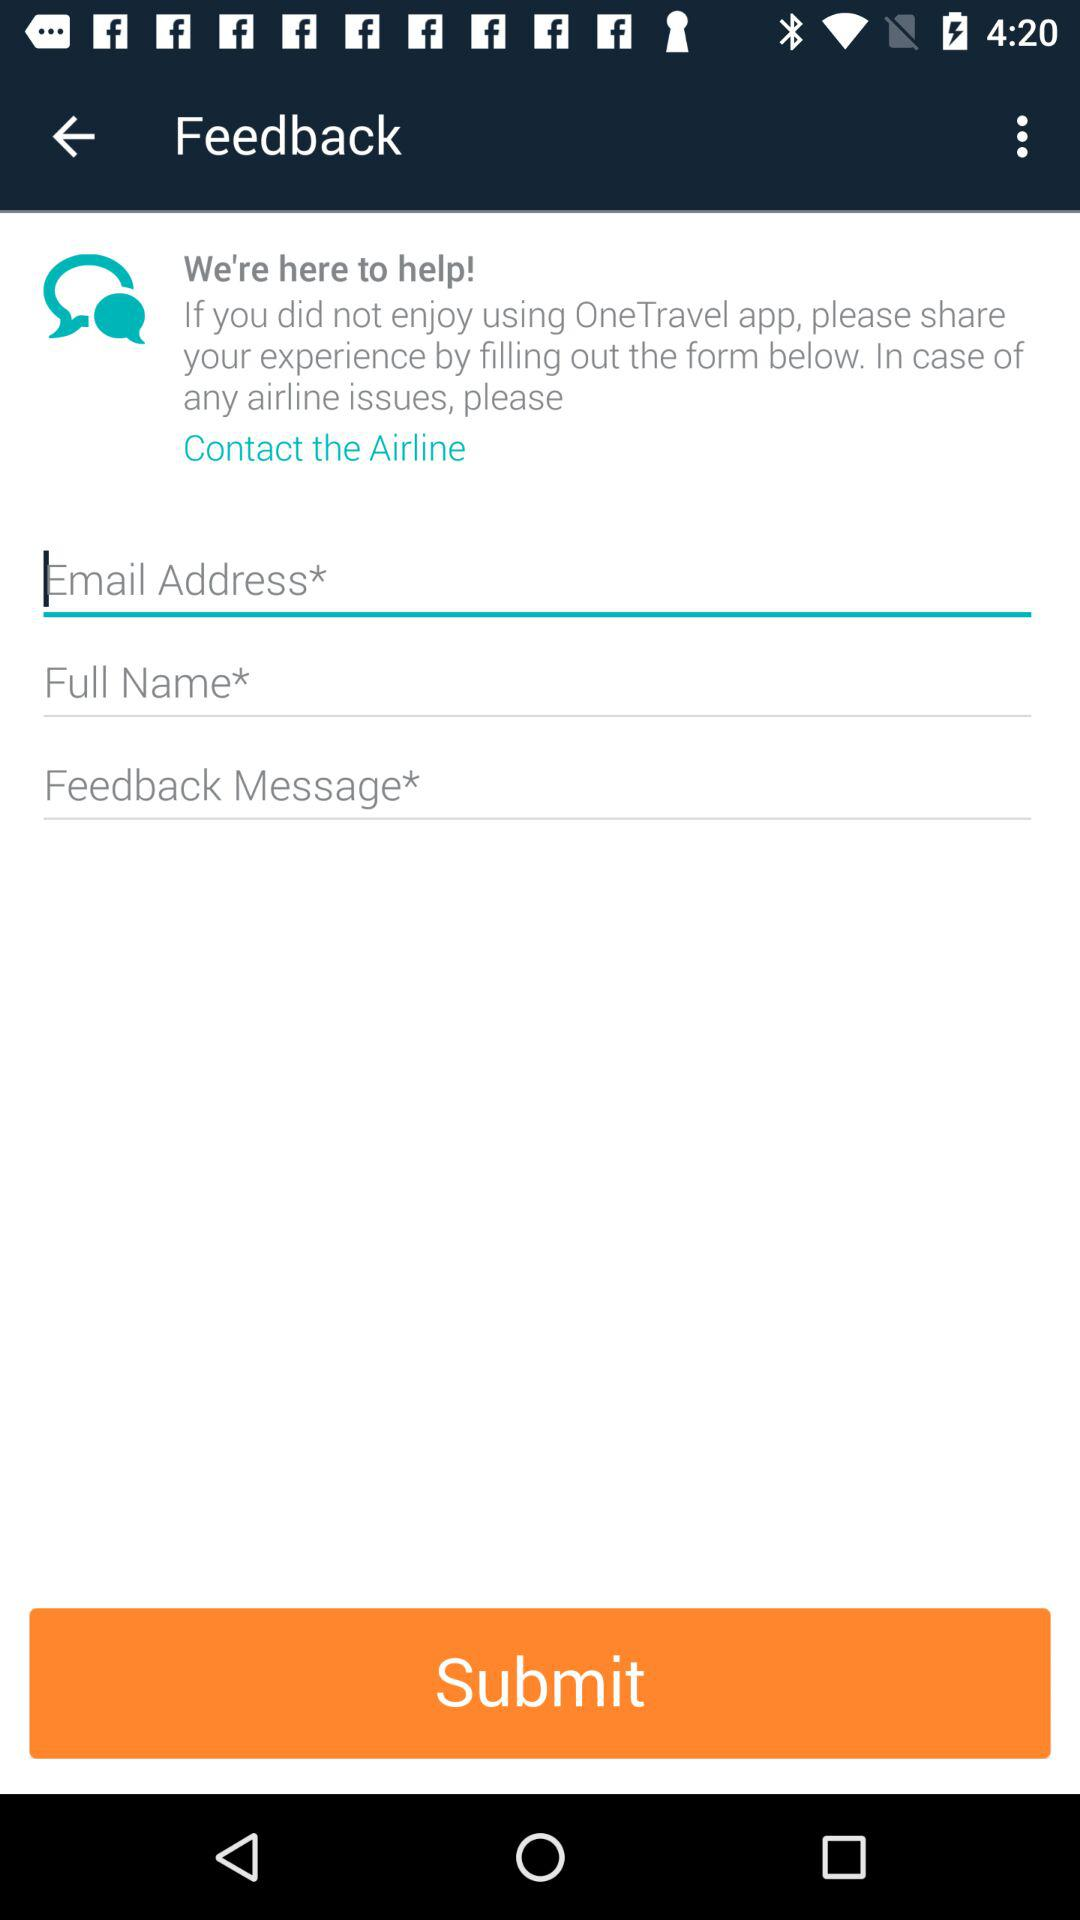How many text inputs are required for users to leave feedback?
Answer the question using a single word or phrase. 3 